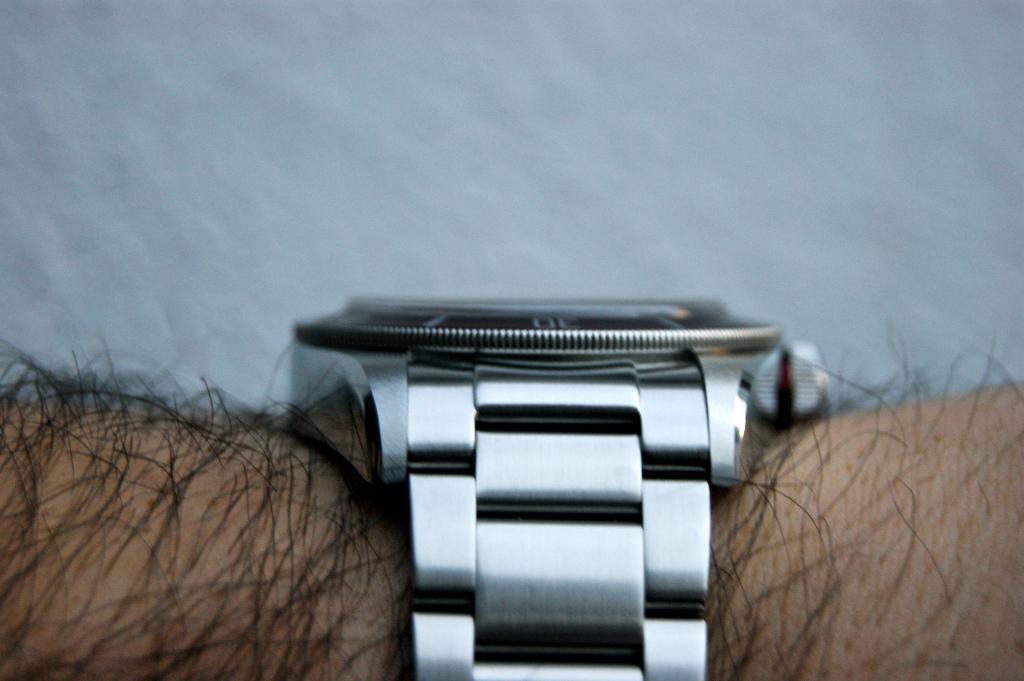Please provide a concise description of this image. As we can see in the image there is a person wearing watch. 